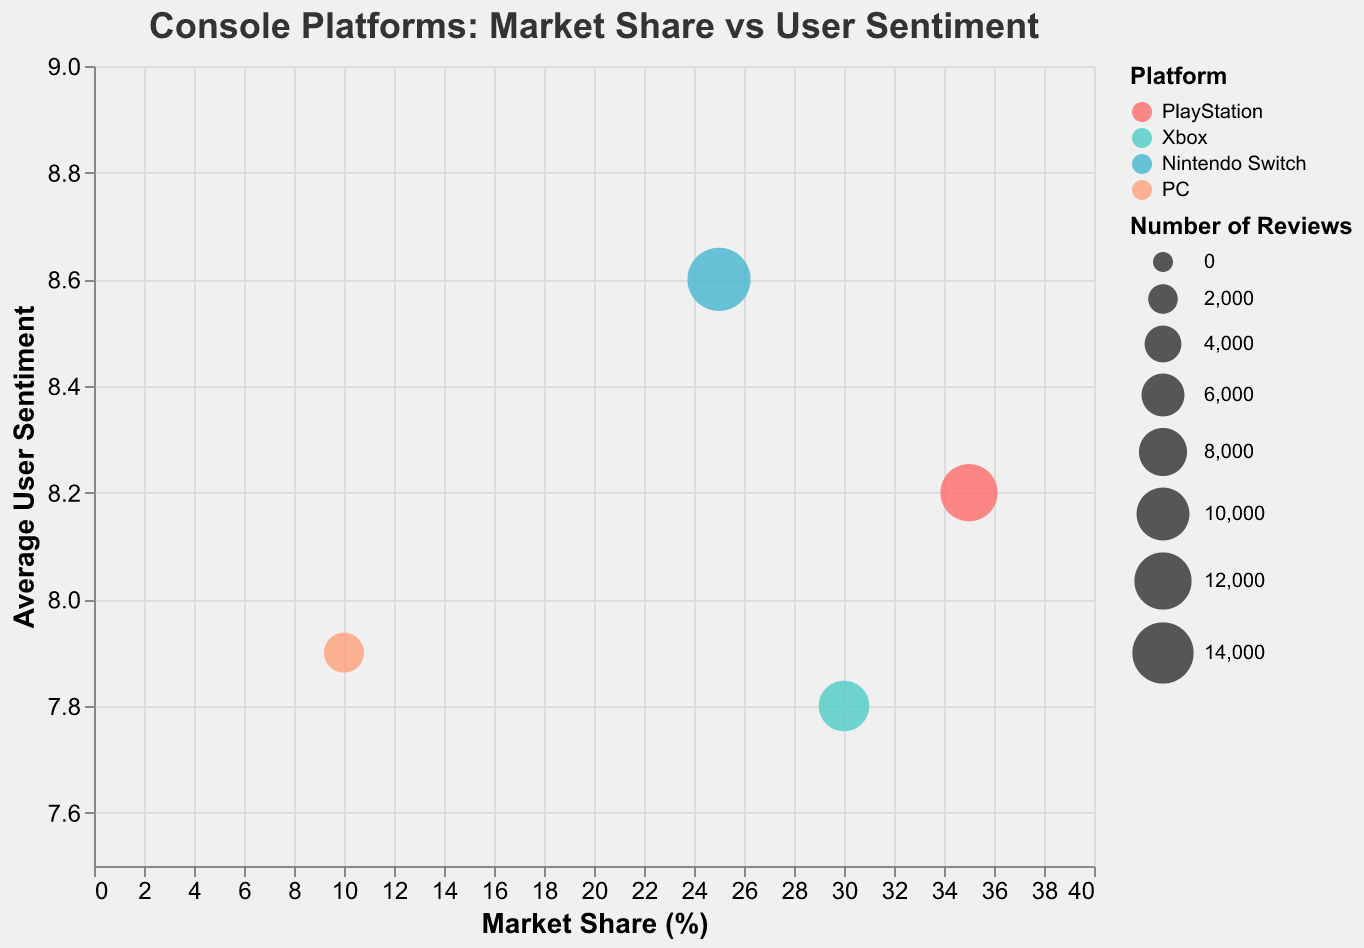What is the title of the figure? The title is usually at the top of the chart. Here, it reads: "Console Platforms: Market Share vs User Sentiment".
Answer: Console Platforms: Market Share vs User Sentiment How many platforms are shown in the chart? By counting the distinct platforms labeled in the color legend, there are four platforms: PlayStation, Xbox, Nintendo Switch, and PC.
Answer: Four Which platform has the highest average user sentiment? Looking at the vertical (y-axis) position of the bubbles, the Nintendo Switch is the highest with an average user sentiment of 8.6.
Answer: Nintendo Switch Which platform has the largest market share? Reviewing the horizontal (x-axis) position of the bubbles, the PlayStation is the furthest right with a market share of 35%.
Answer: PlayStation Which platform has the most reviews? The size of the bubbles indicates the number of reviews. The largest bubble corresponds to Nintendo Switch with 15,000 reviews.
Answer: Nintendo Switch What is the market share difference between PlayStation and Xbox? Subtracting the market share percentage of Xbox (30%) from PlayStation (35%) gives 5%.
Answer: 5% How does the user sentiment of PC compare to Xbox? By comparing the vertical positions on the y-axis, the PC has a marginally higher user sentiment (7.9) compared to Xbox (7.8).
Answer: PC's sentiment is higher Rank the platforms by the number of reviews. From largest to smallest bubbles, the order is Nintendo Switch (15,000), PlayStation (12,000), Xbox (9,000), and PC (5,000).
Answer: Nintendo Switch, PlayStation, Xbox, PC Which platform has the lowest average user sentiment? By looking at the vertical (y-axis) position of the bubbles, Xbox has the lowest average user sentiment of 7.8.
Answer: Xbox Is there a strong correlation between market share and average user sentiment? Observing the scatter distribution of bubbles, there is no obvious strong trend linking market share on the x-axis to user sentiment on the y-axis.
Answer: No 